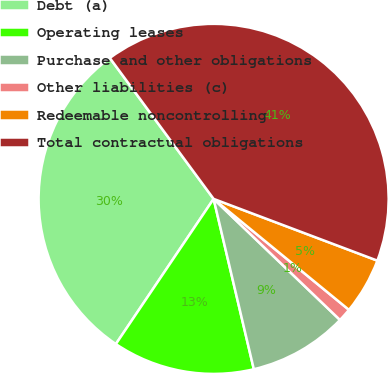Convert chart. <chart><loc_0><loc_0><loc_500><loc_500><pie_chart><fcel>Debt (a)<fcel>Operating leases<fcel>Purchase and other obligations<fcel>Other liabilities (c)<fcel>Redeemable noncontrolling<fcel>Total contractual obligations<nl><fcel>30.46%<fcel>13.12%<fcel>9.15%<fcel>1.23%<fcel>5.19%<fcel>40.84%<nl></chart> 